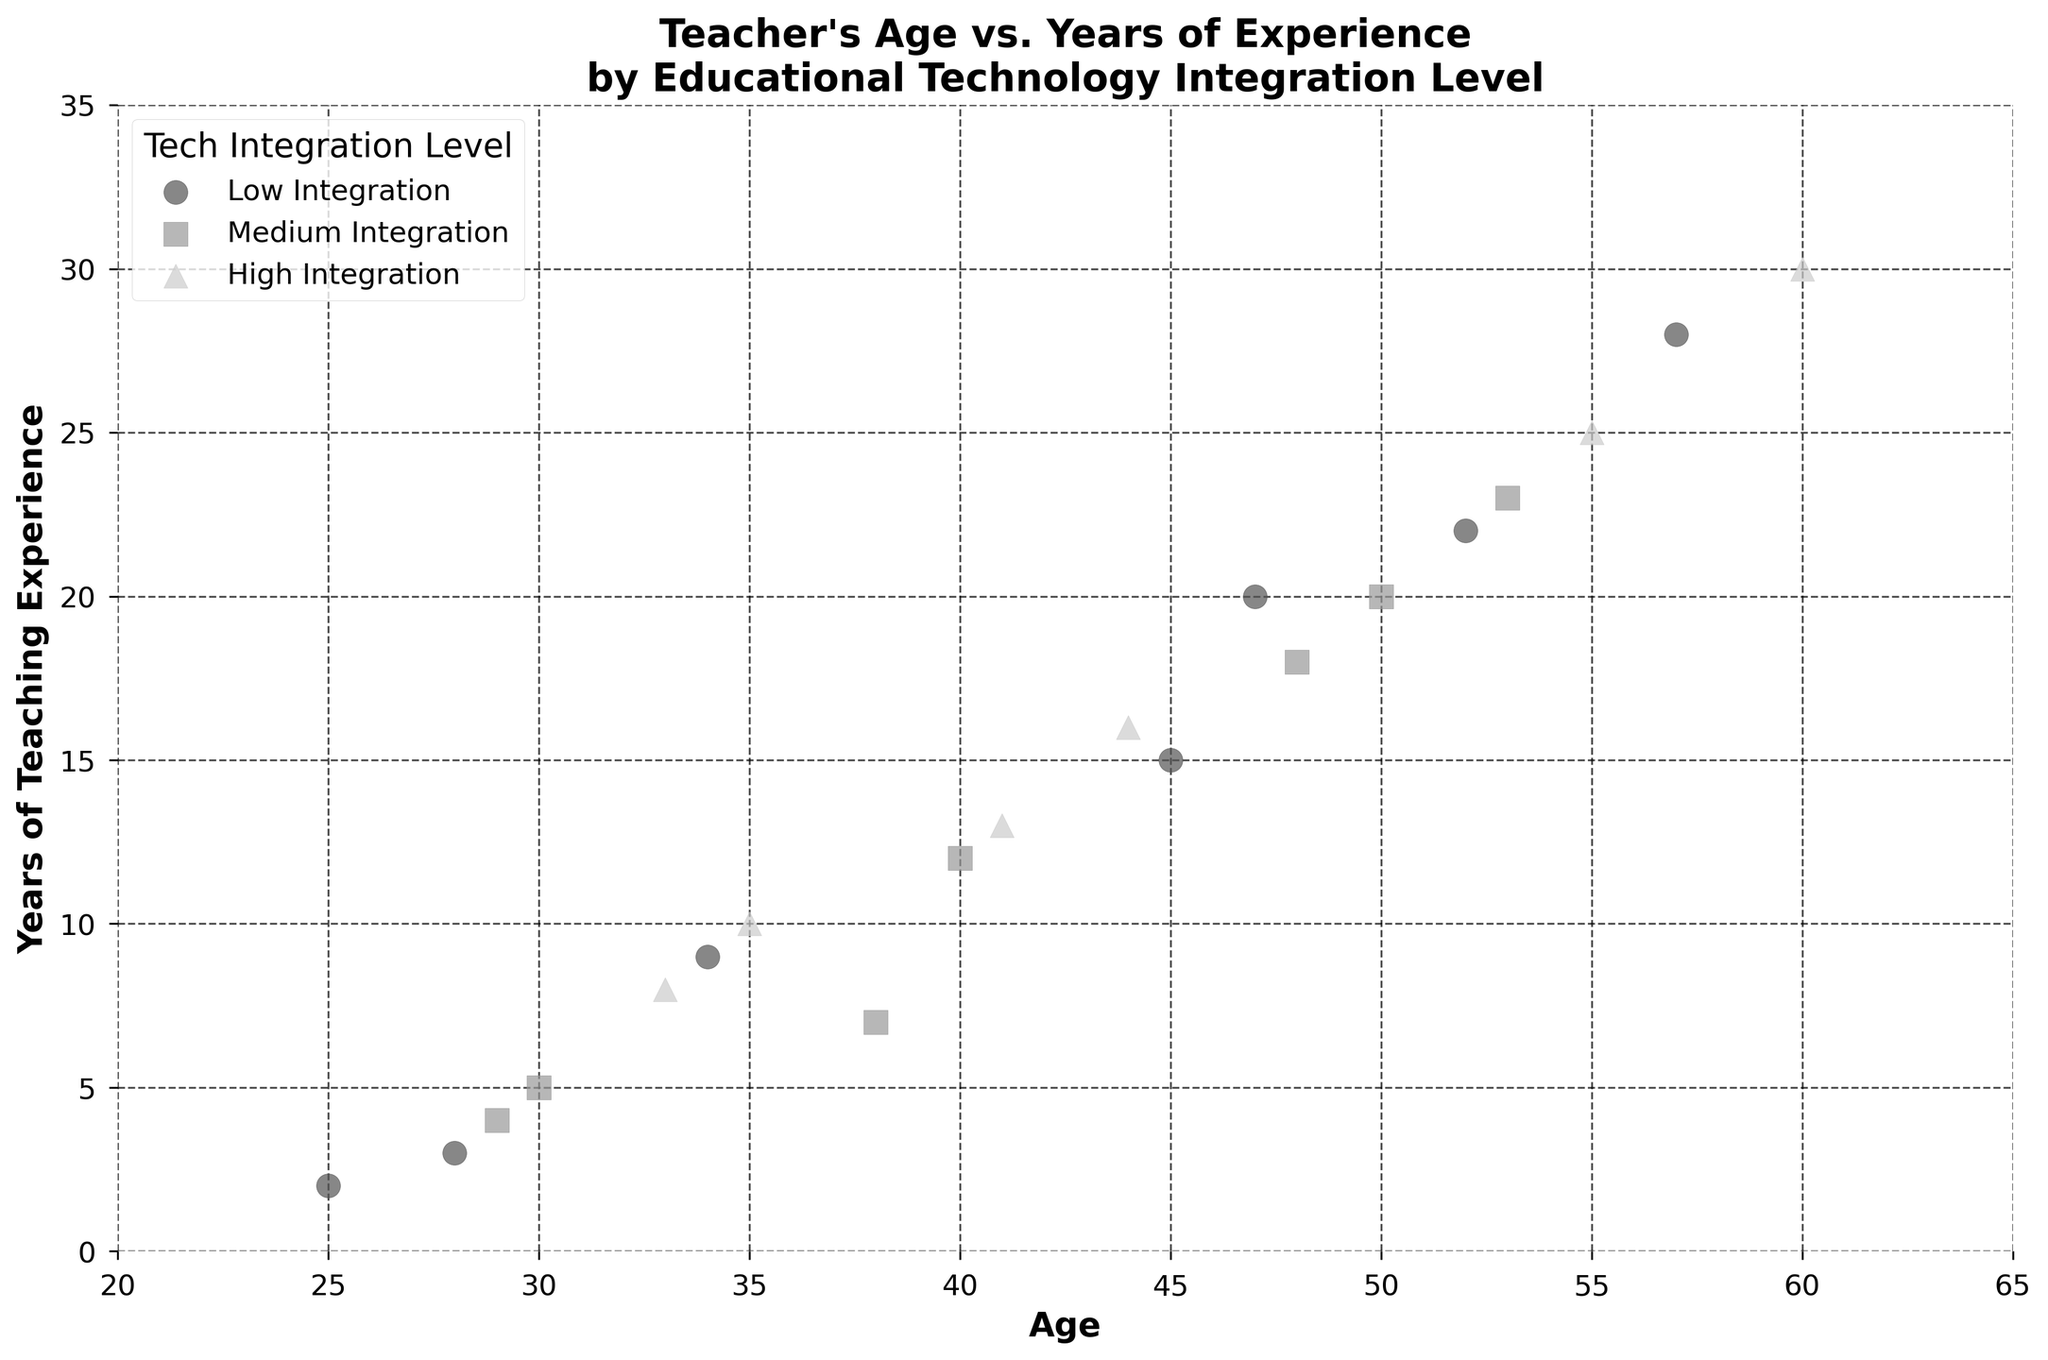What is the title of the figure? The title is prominently displayed at the top of the figure.
Answer: Teacher's Age vs. Years of Experience by Educational Technology Integration Level How many levels of educational technology integration are represented in the plot? The legend at the top left of the plot shows three different levels of educational technology integration.
Answer: Three What marker shape is used to represent Low integration teachers? By looking at the scatter plot, the marker shapes can be identified.
Answer: Circles What is the range of ages shown in the plot? Observing the x-axis, which represents age, we can see the range from the minimum to the maximum value.
Answer: 20 to 65 Which group contains a teacher who is 60 years old? By identifying the point at age 60 and then checking the legend or the marker color and shape, we can determine the group.
Answer: High What is the maximum teaching experience among teachers with Medium tech integration? Locate all markers representing Medium integration and find the maximum value on the y-axis (years of experience).
Answer: 23 years How many teachers with High tech integration have more than 20 years of experience? Identify the points with High integration and check which of these are above the 20-year mark on the y-axis.
Answer: Two Compare the average age of teachers within each tech integration level. Calculate the average age for each tech integration group by summing their ages and dividing by the number of data points in each group.
Answer: Low: 45.7, Medium: 43.8, High: 48.6 Which tech integration level has the most teachers under the age of 40? Count the data points for each tech integration level that fall below the age of 40 on the x-axis.
Answer: Medium Is there a visible trend between age and years of experience across different tech integration levels? Analyze if older teachers tend to have more years of experience, and check if that trend is consistent within each tech integration group.
Answer: Yes, older teachers generally have more experience across all levels 